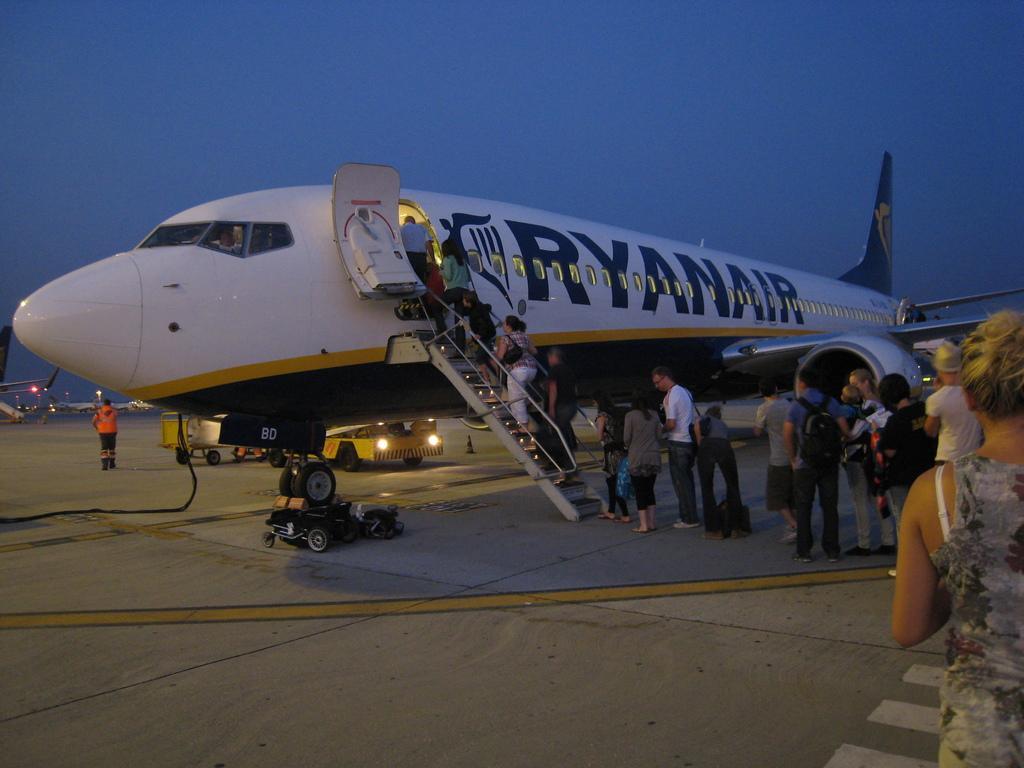How would you summarize this image in a sentence or two? In this image we can see people, plane, blue sky, vehicle and things. 